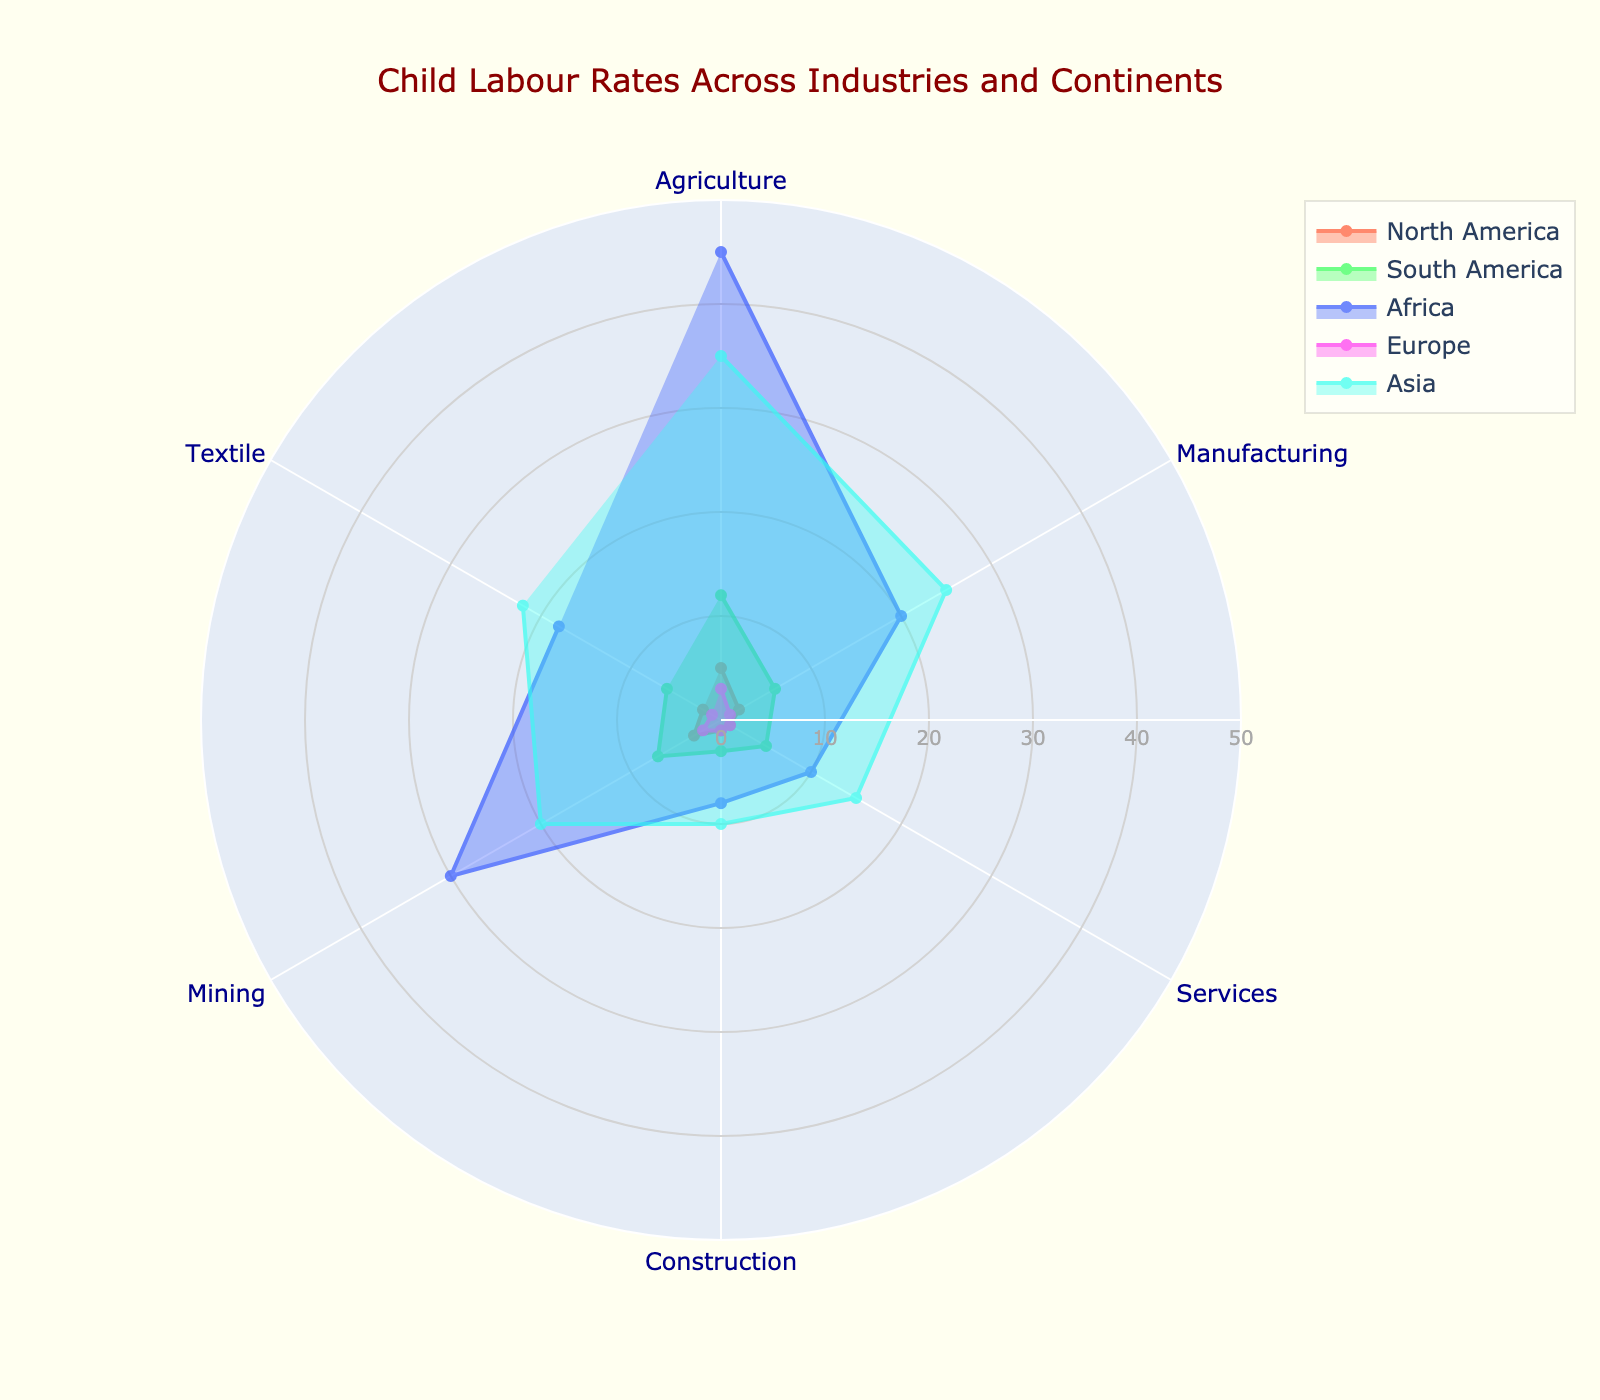What is the highest child labour rate in the Agriculture industry? Look at the 'Agriculture' axis on the radar chart and identify which continent has the highest value.
Answer: 45 in Africa Which industry has the lowest child labour rate in South America? Check the 'South America' values across different industries and identify the industry with the smallest value.
Answer: Construction with 3 How does the child labour rate in the Textile industry in Asia compare to that in Africa? Compare the values of the Textile industry for Asia and Africa on the radar chart.
Answer: Asia (22) is higher than Africa (18) In which industry do North America and Europe have the same child labour rate? Scan through the radar chart to find an industry where the data points for North America and Europe overlap.
Answer: Services, both have 1 What is the average child labour rate in the Manufacturing industry across all continents? Sum the values for the Manufacturing industry across all continents and divide by the number of continents. (2 + 6 + 20 + 1 + 25) / 5 = 54 / 5
Answer: 10.8 Which continent has the highest average child labour rate across all industries? Calculate the average child labour rate for each continent by summing their industry values and dividing by the number of industries, then identify the highest. Africa: (45+20+10+8+30+18)=131/6=21.83, Asia: (35+25+15+10+20+22)=127/6=21.17, North America: 14/6=2.33, South America: 39/6=6.5, Europe: 9/6=1.5. Africa has the highest average.
Answer: Africa What is the difference in child labour rates between Mining and Services industries in Asia? Subtract the child labour rate in the Services industry in Asia from that in the Mining industry in Asia: 20 - 15 = 5.
Answer: 5 Which industry shows the highest variability in child labour rates across different continents? Identify the industry with the most significant differences between its high and low values across continents. Agriculture ranges from 3 to 45 (42 units), while others have smaller ranges.
Answer: Agriculture What are the total child labour rates in the Transportation and Construction industries in Europe? Sum the data points for the Transportation industry in Europe (not applicable here, assume lowest industry rate) and the Construction industry in Europe: 1.
Answer: 1 Are there any industries where Asia leads in child labour rates? Compare each industry's data for Asia with those of other continents to see if Asia has the highest value in any cases.
Answer: Yes, Agriculture and Manufacturing 